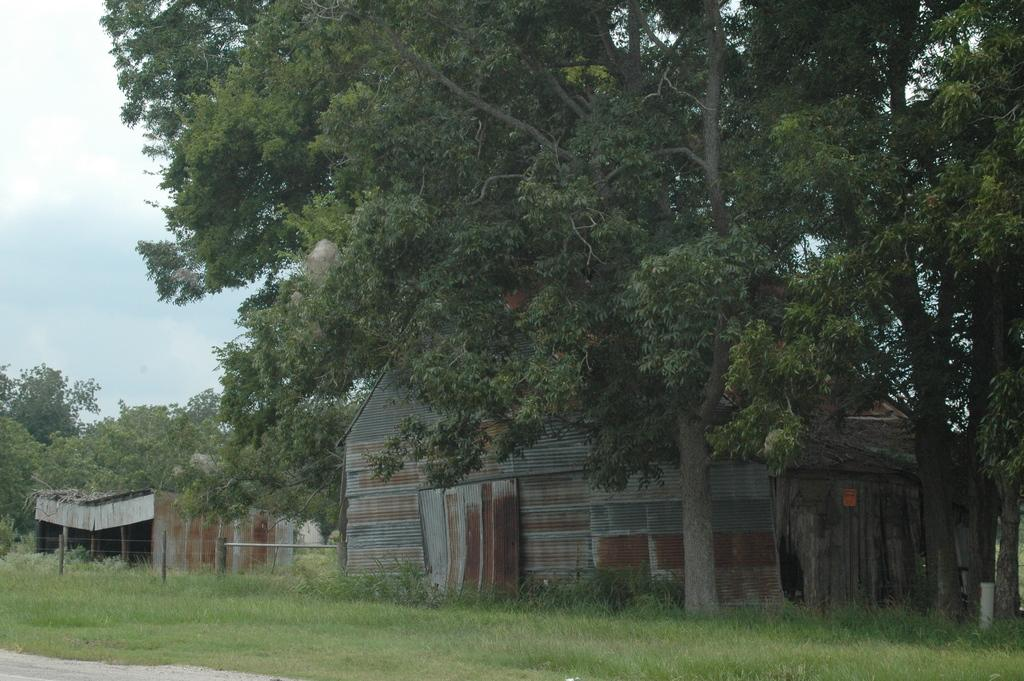What type of vegetation is present in the image? There is grass in the image. What type of structures can be seen in the image? There are sheds in the image. What other natural elements are visible in the image? There are trees in the image. What else can be seen in the image besides the grass, sheds, and trees? There are objects in the image. How would you describe the weather based on the image? The sky is cloudy in the image. What type of quill is being used to write on the shed in the image? There is no quill or writing activity present in the image. What type of voice can be heard coming from the trees in the image? There is no voice or sound coming from the trees in the image. 